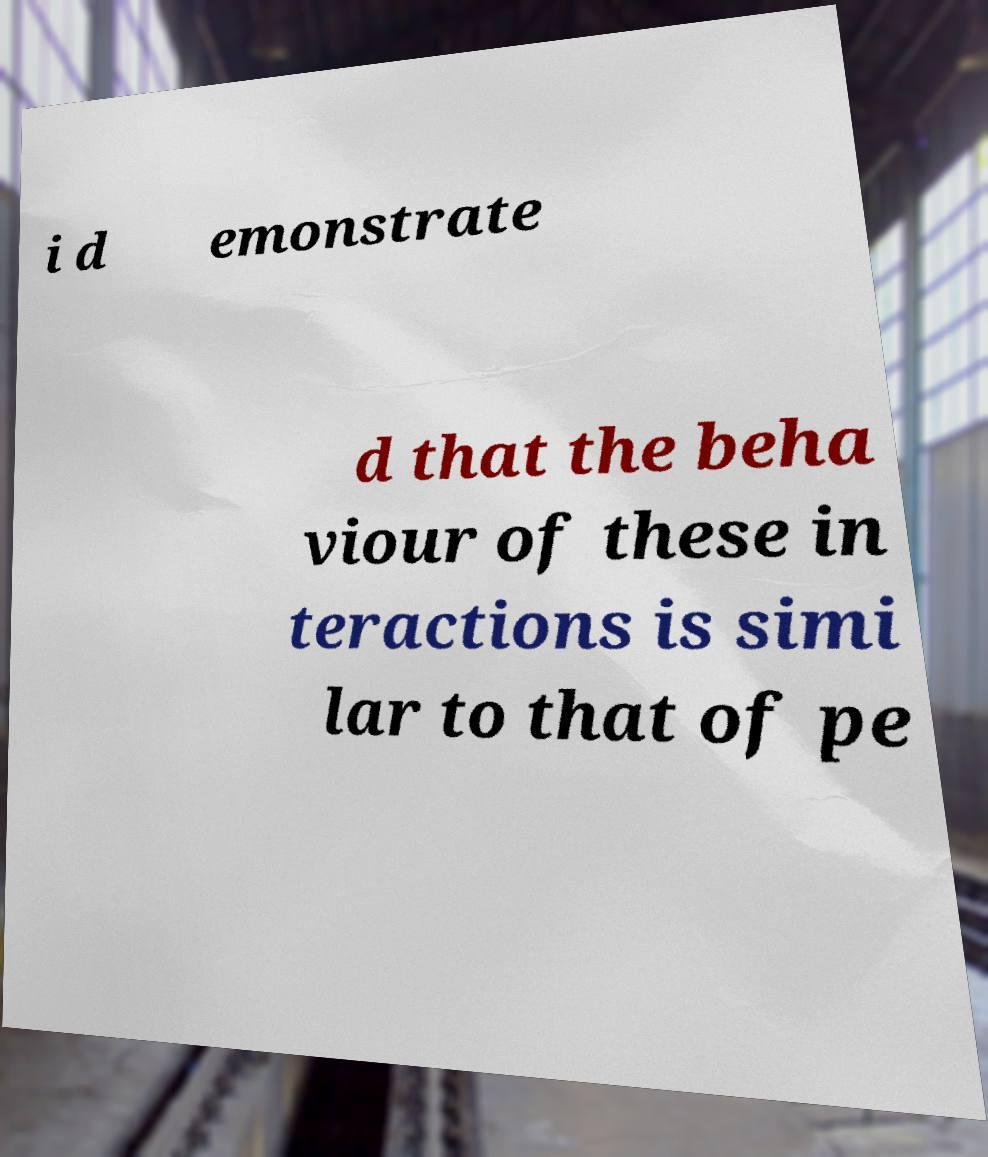Please read and relay the text visible in this image. What does it say? i d emonstrate d that the beha viour of these in teractions is simi lar to that of pe 